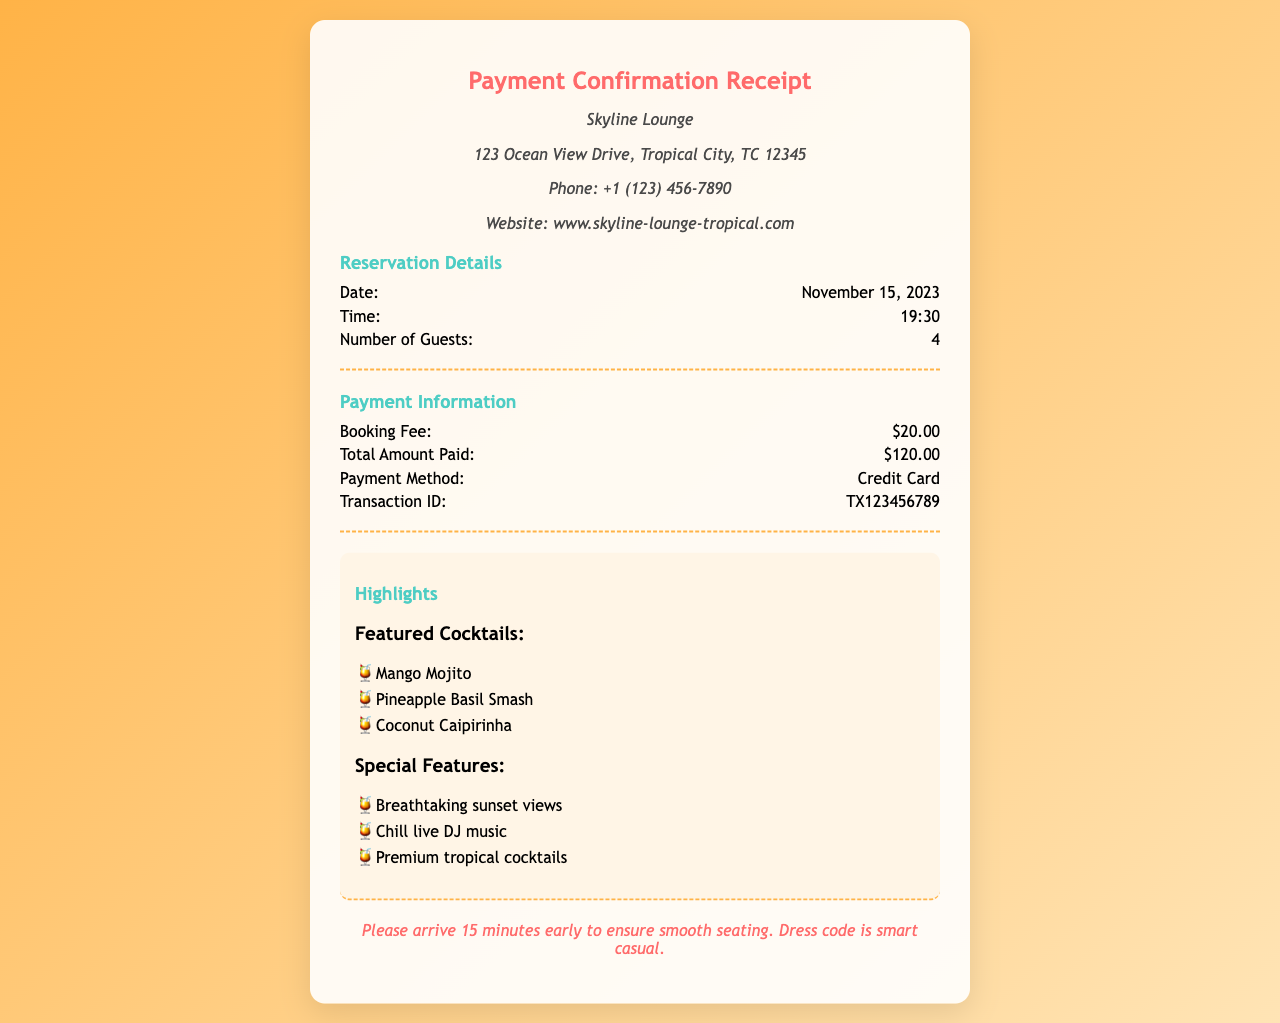What is the reservation date? The reservation date is specified in the document.
Answer: November 15, 2023 What is the booking fee? The booking fee is listed under Payment Information.
Answer: $20.00 What time is the reservation? The reservation time is indicated in the details section.
Answer: 19:30 What is the number of guests for the reservation? The number of guests is mentioned in the reservation details.
Answer: 4 What is the total amount paid? The total amount paid is stated in the Payment Information section.
Answer: $120.00 What is the payment method? The payment method can be found in the Payment Information section.
Answer: Credit Card What is the transaction ID? The transaction ID is specified in the payment section of the document.
Answer: TX123456789 What are the featured cocktails mentioned? Featured cocktails are listed under the highlights section.
Answer: Mango Mojito, Pineapple Basil Smash, Coconut Caipirinha What do guests need to ensure a smooth seating? The document includes a note regarding arrival time for seating.
Answer: Arrive 15 minutes early What is the dress code? The dress code is mentioned in the notes section of the receipt.
Answer: Smart casual 